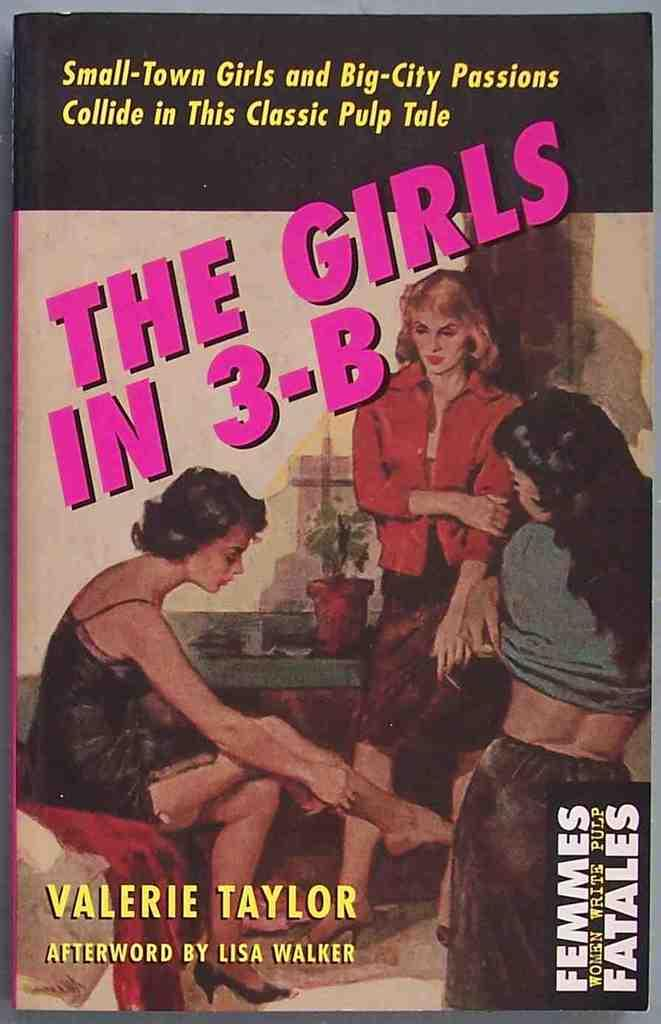<image>
Offer a succinct explanation of the picture presented. A Book written by Valerie Taylor has three girls on the cover. 